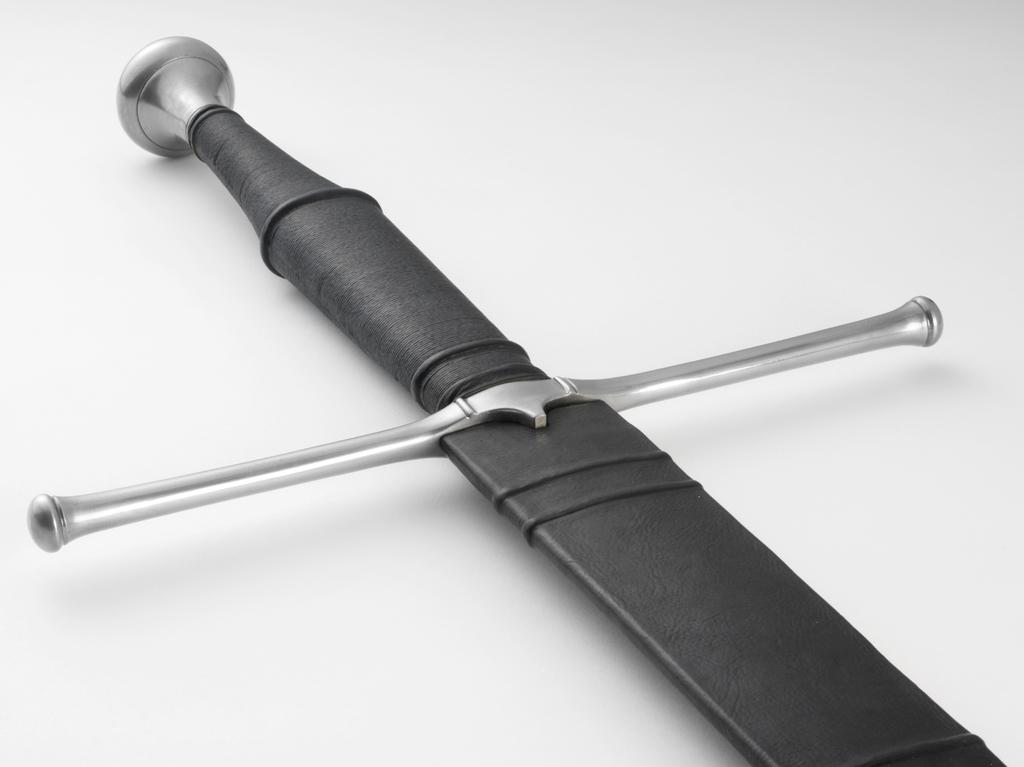What object is the main focus of the image? There is a sword in the image. What part of the sword is used for gripping? The sword has a handle. What is the color of the handle? The handle is black in color. What type of bean is growing on the sword in the image? There are no beans present in the image, and the sword is not a plant or a growing medium for beans. 